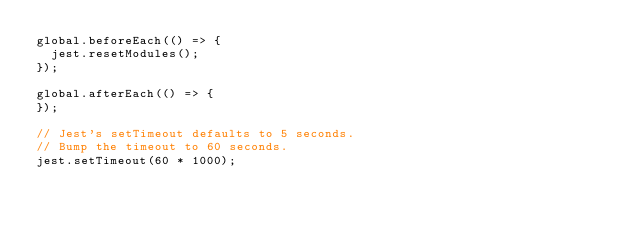Convert code to text. <code><loc_0><loc_0><loc_500><loc_500><_JavaScript_>global.beforeEach(() => {
  jest.resetModules();
});

global.afterEach(() => {
});

// Jest's setTimeout defaults to 5 seconds.
// Bump the timeout to 60 seconds.
jest.setTimeout(60 * 1000);
</code> 